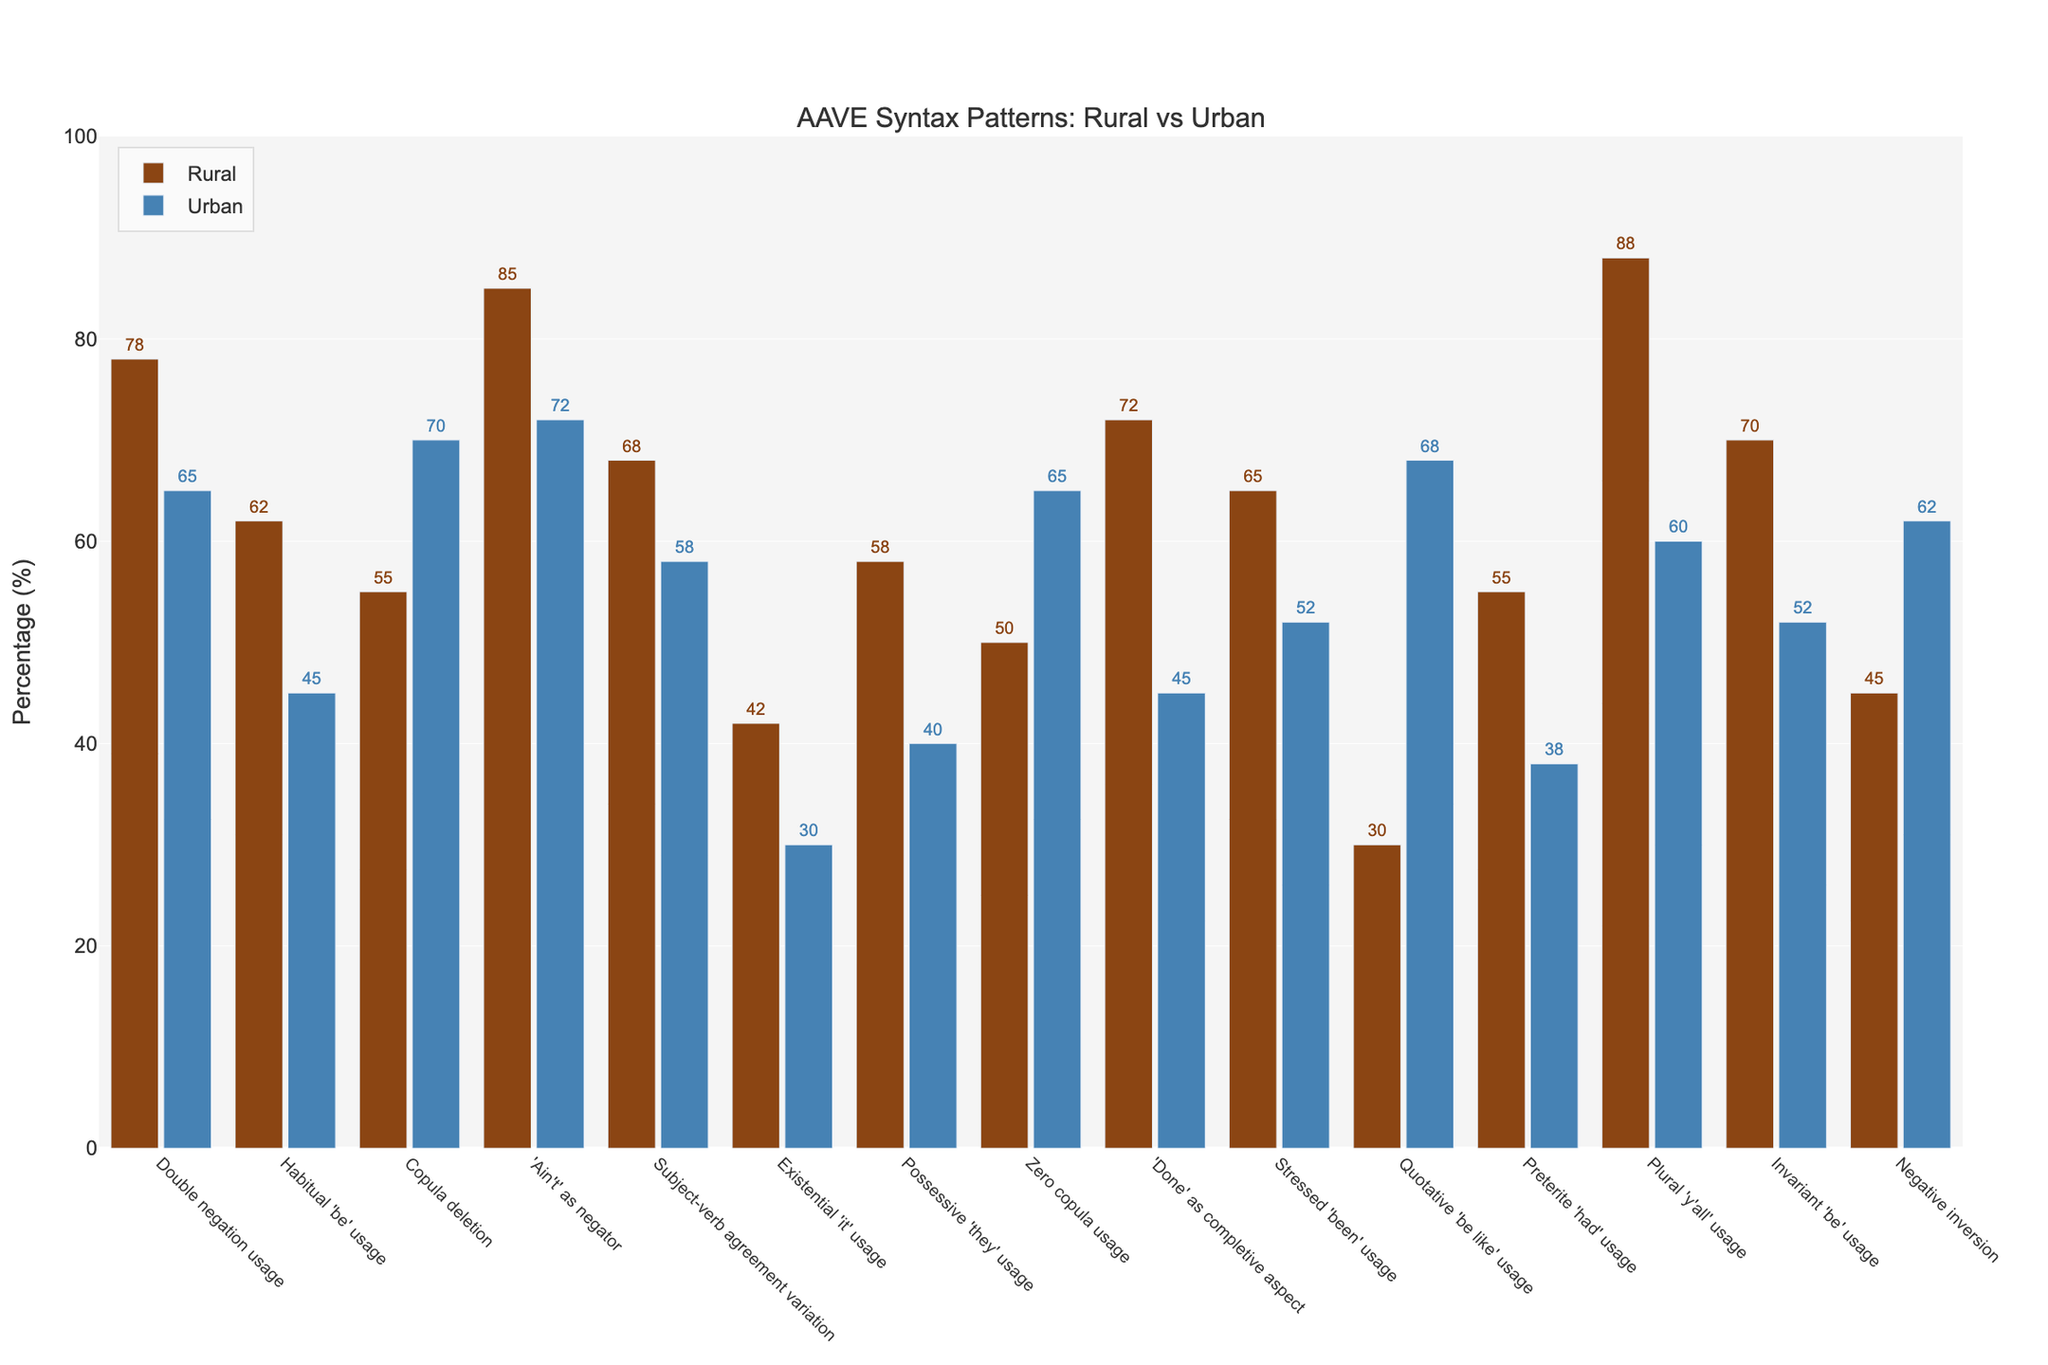Which feature shows the highest usage percentage in rural communities? Look at the bar heights for all features on the rural side and find the highest one. The tallest bar belongs to "Plural 'y'all' usage" at 88%.
Answer: Plural 'y'all' usage Which feature is most prevalent in urban communities? Examine the bar heights for all features on the urban side and identify the tallest one, which is "Quotative 'be like' usage" at 68%.
Answer: Quotative 'be like' usage What is the difference in "Double negation usage" between rural and urban communities? Find the height of the "Double negation usage" bar for both rural (78%) and urban (65%) and subtract urban from rural: 78 - 65 = 13%.
Answer: 13% Which feature has the smallest difference in percentage between rural and urban communities? Compare the differences between the rural and urban percentages for all features. "Existential 'it' usage" has the smallest difference: 42 - 30 = 12%.
Answer: Existential 'it' usage What is the average percentage usage of "Habitual 'be' usage" and "Invariant 'be' usage" in urban communities? First, sum the urban percentages for "Habitual 'be' usage" (45%) and "Invariant 'be' usage" (52%). Then divide by 2: (45 + 52) / 2 = 48.5%.
Answer: 48.5% By how much does the rural usage of "Zero copula usage" differ from urban usage? Check the bar heights for "Zero copula usage" in both rural (50%) and urban (65%), then subtract rural from urban: 65 - 50 = 15%.
Answer: 15% Which feature shows the greatest variation between rural and urban usage? Find the differences between rural and urban percentages for all features and identify the largest difference. "Plural 'y'all' usage" varies the most: 88 - 60 = 28%.
Answer: Plural 'y'all' usage Which community shows higher usage for "Negative inversion"? Compare the bar heights for "Negative inversion" in rural (45%) and urban (62%). The urban community has a higher usage.
Answer: Urban What is the combined percentage of "Subject-verb agreement variation" in both rural and urban communities? Add the rural percentage (68%) and urban percentage (58%) for "Subject-verb agreement variation": 68 + 58 = 126%.
Answer: 126% For "Copula deletion," which community has a higher percentage, and by how much? Compare the bar heights for "Copula deletion" in rural (55%) and urban (70%). Urban is higher, and the difference is 70 - 55 = 15%.
Answer: Urban, 15% 